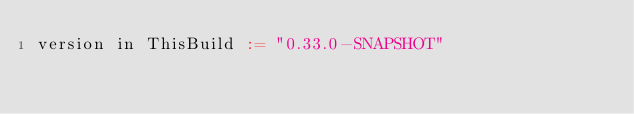<code> <loc_0><loc_0><loc_500><loc_500><_Scala_>version in ThisBuild := "0.33.0-SNAPSHOT"
</code> 